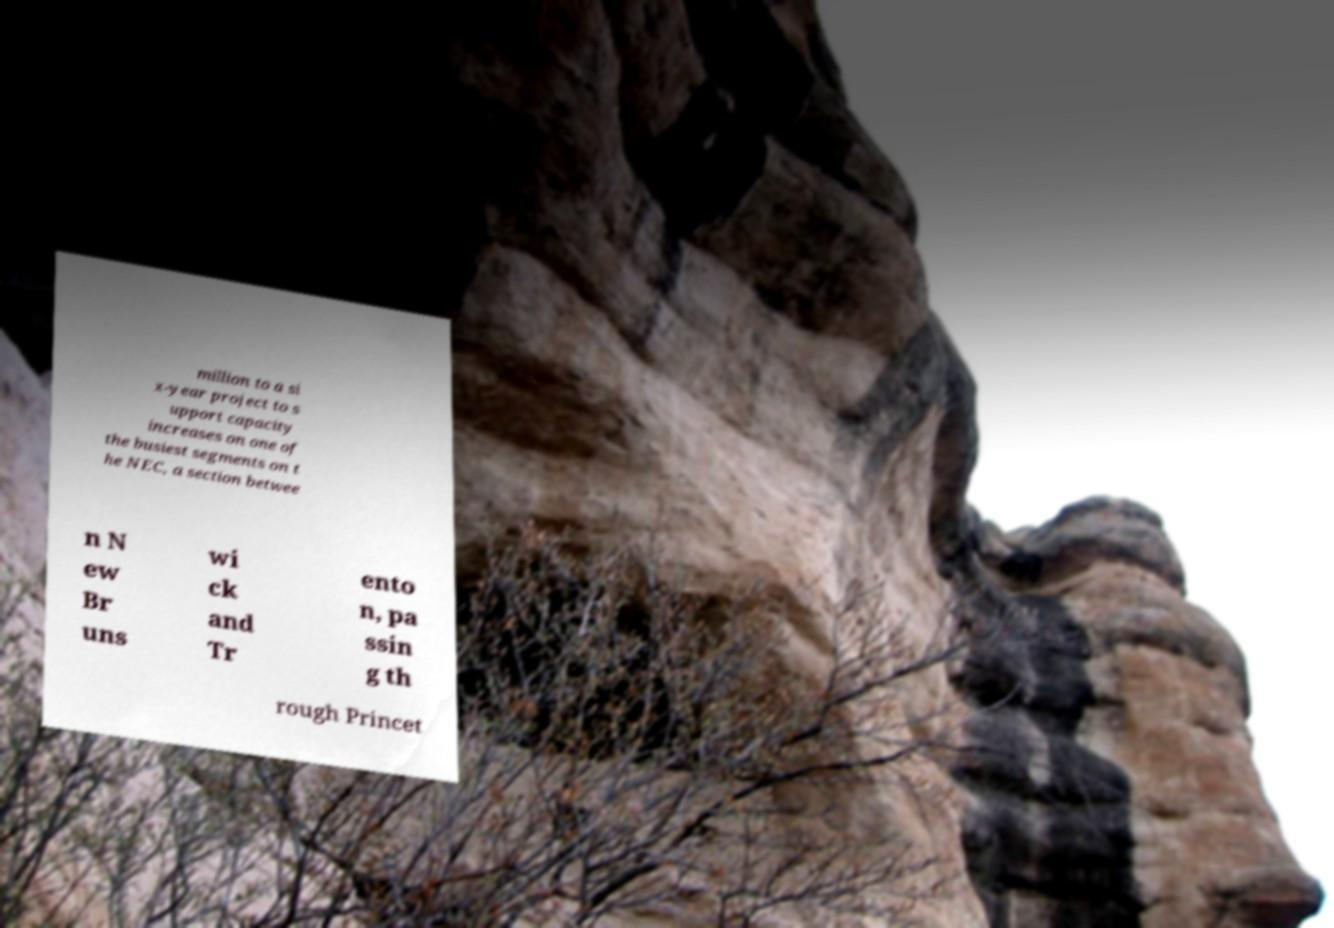What messages or text are displayed in this image? I need them in a readable, typed format. million to a si x-year project to s upport capacity increases on one of the busiest segments on t he NEC, a section betwee n N ew Br uns wi ck and Tr ento n, pa ssin g th rough Princet 